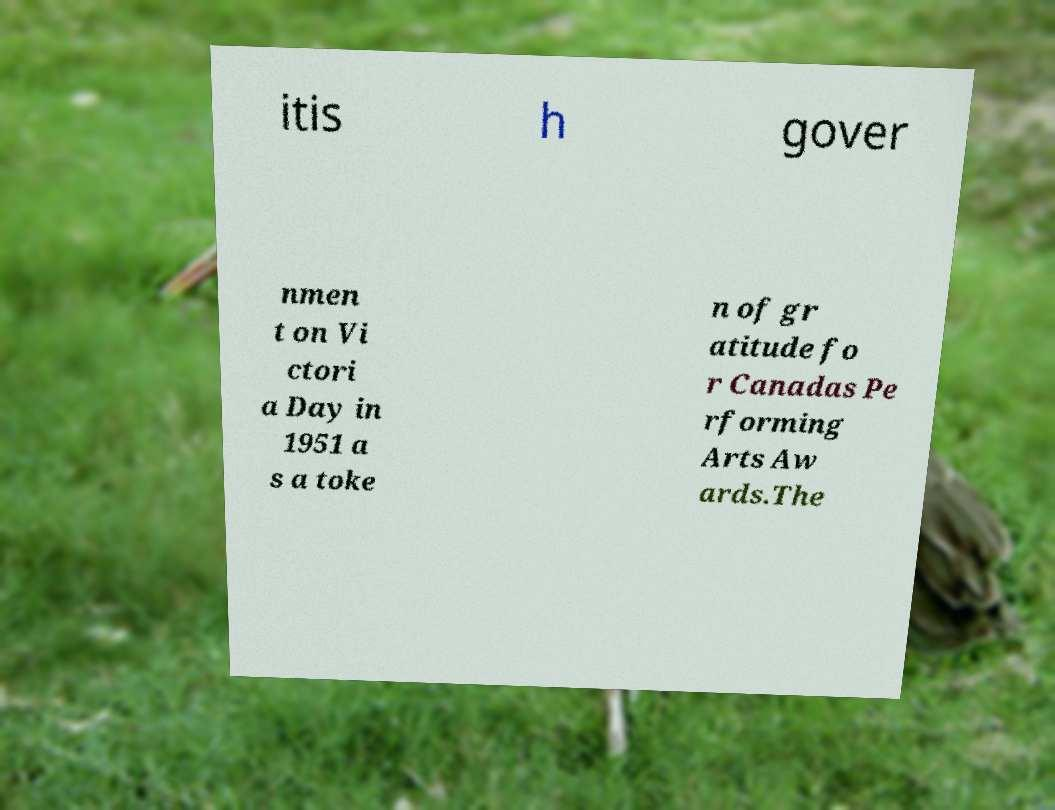Can you accurately transcribe the text from the provided image for me? itis h gover nmen t on Vi ctori a Day in 1951 a s a toke n of gr atitude fo r Canadas Pe rforming Arts Aw ards.The 